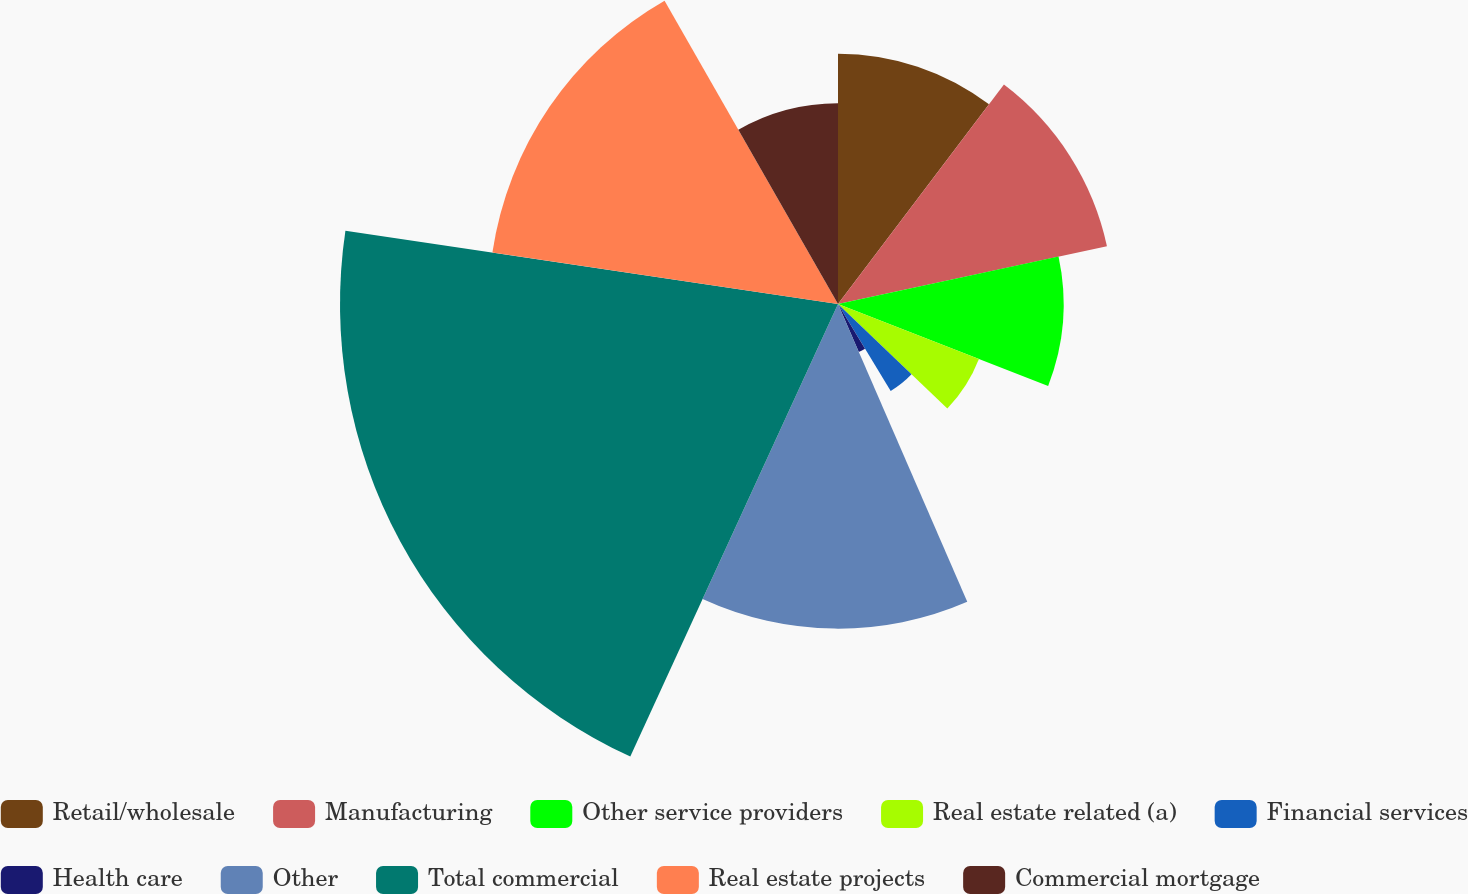Convert chart to OTSL. <chart><loc_0><loc_0><loc_500><loc_500><pie_chart><fcel>Retail/wholesale<fcel>Manufacturing<fcel>Other service providers<fcel>Real estate related (a)<fcel>Financial services<fcel>Health care<fcel>Other<fcel>Total commercial<fcel>Real estate projects<fcel>Commercial mortgage<nl><fcel>10.31%<fcel>11.33%<fcel>9.29%<fcel>6.23%<fcel>4.19%<fcel>2.15%<fcel>13.37%<fcel>20.51%<fcel>14.39%<fcel>8.27%<nl></chart> 